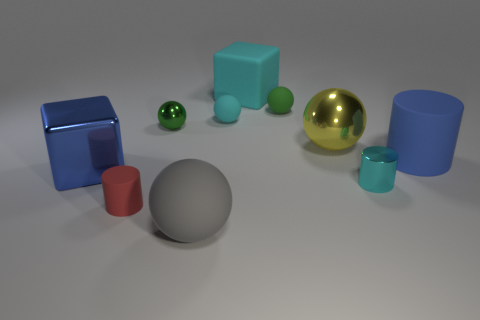What color is the tiny cylinder to the right of the red matte cylinder?
Offer a terse response. Cyan. The gray ball that is the same material as the cyan cube is what size?
Give a very brief answer. Large. There is a gray rubber ball; is it the same size as the matte cylinder that is right of the large yellow metal object?
Make the answer very short. Yes. What is the small cylinder that is to the left of the cyan rubber cube made of?
Provide a short and direct response. Rubber. How many shiny objects are behind the cyan thing in front of the big cylinder?
Your answer should be very brief. 3. Are there any green metal objects that have the same shape as the green matte thing?
Offer a terse response. Yes. Is the size of the matte cylinder that is right of the cyan metal object the same as the object that is left of the small matte cylinder?
Keep it short and to the point. Yes. What shape is the blue thing on the left side of the cyan shiny cylinder to the right of the small green metal object?
Provide a short and direct response. Cube. What number of green shiny balls are the same size as the cyan shiny thing?
Make the answer very short. 1. Is there a big matte block?
Provide a short and direct response. Yes. 